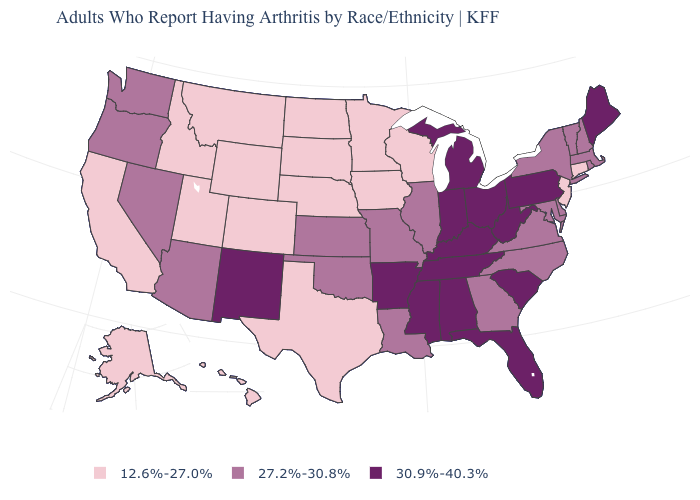Which states have the highest value in the USA?
Keep it brief. Alabama, Arkansas, Florida, Indiana, Kentucky, Maine, Michigan, Mississippi, New Mexico, Ohio, Pennsylvania, South Carolina, Tennessee, West Virginia. Which states have the lowest value in the USA?
Quick response, please. Alaska, California, Colorado, Connecticut, Hawaii, Idaho, Iowa, Minnesota, Montana, Nebraska, New Jersey, North Dakota, South Dakota, Texas, Utah, Wisconsin, Wyoming. What is the value of Massachusetts?
Quick response, please. 27.2%-30.8%. Which states have the highest value in the USA?
Quick response, please. Alabama, Arkansas, Florida, Indiana, Kentucky, Maine, Michigan, Mississippi, New Mexico, Ohio, Pennsylvania, South Carolina, Tennessee, West Virginia. Name the states that have a value in the range 12.6%-27.0%?
Be succinct. Alaska, California, Colorado, Connecticut, Hawaii, Idaho, Iowa, Minnesota, Montana, Nebraska, New Jersey, North Dakota, South Dakota, Texas, Utah, Wisconsin, Wyoming. Does Ohio have the lowest value in the MidWest?
Be succinct. No. Among the states that border Nevada , which have the highest value?
Answer briefly. Arizona, Oregon. Does Washington have the lowest value in the USA?
Give a very brief answer. No. Does the map have missing data?
Be succinct. No. Among the states that border Indiana , does Illinois have the lowest value?
Short answer required. Yes. Name the states that have a value in the range 27.2%-30.8%?
Quick response, please. Arizona, Delaware, Georgia, Illinois, Kansas, Louisiana, Maryland, Massachusetts, Missouri, Nevada, New Hampshire, New York, North Carolina, Oklahoma, Oregon, Rhode Island, Vermont, Virginia, Washington. Does the first symbol in the legend represent the smallest category?
Concise answer only. Yes. Which states have the lowest value in the USA?
Answer briefly. Alaska, California, Colorado, Connecticut, Hawaii, Idaho, Iowa, Minnesota, Montana, Nebraska, New Jersey, North Dakota, South Dakota, Texas, Utah, Wisconsin, Wyoming. Is the legend a continuous bar?
Answer briefly. No. 